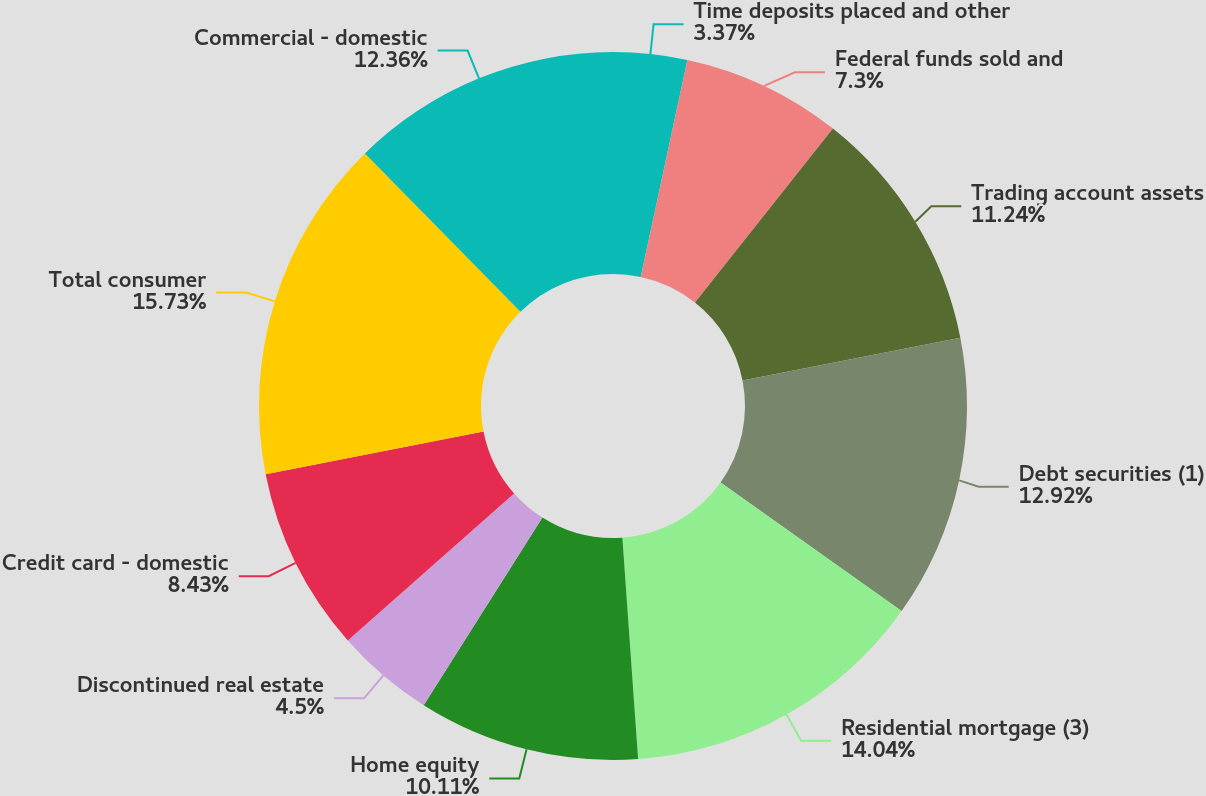Convert chart to OTSL. <chart><loc_0><loc_0><loc_500><loc_500><pie_chart><fcel>Time deposits placed and other<fcel>Federal funds sold and<fcel>Trading account assets<fcel>Debt securities (1)<fcel>Residential mortgage (3)<fcel>Home equity<fcel>Discontinued real estate<fcel>Credit card - domestic<fcel>Total consumer<fcel>Commercial - domestic<nl><fcel>3.37%<fcel>7.3%<fcel>11.24%<fcel>12.92%<fcel>14.04%<fcel>10.11%<fcel>4.5%<fcel>8.43%<fcel>15.73%<fcel>12.36%<nl></chart> 